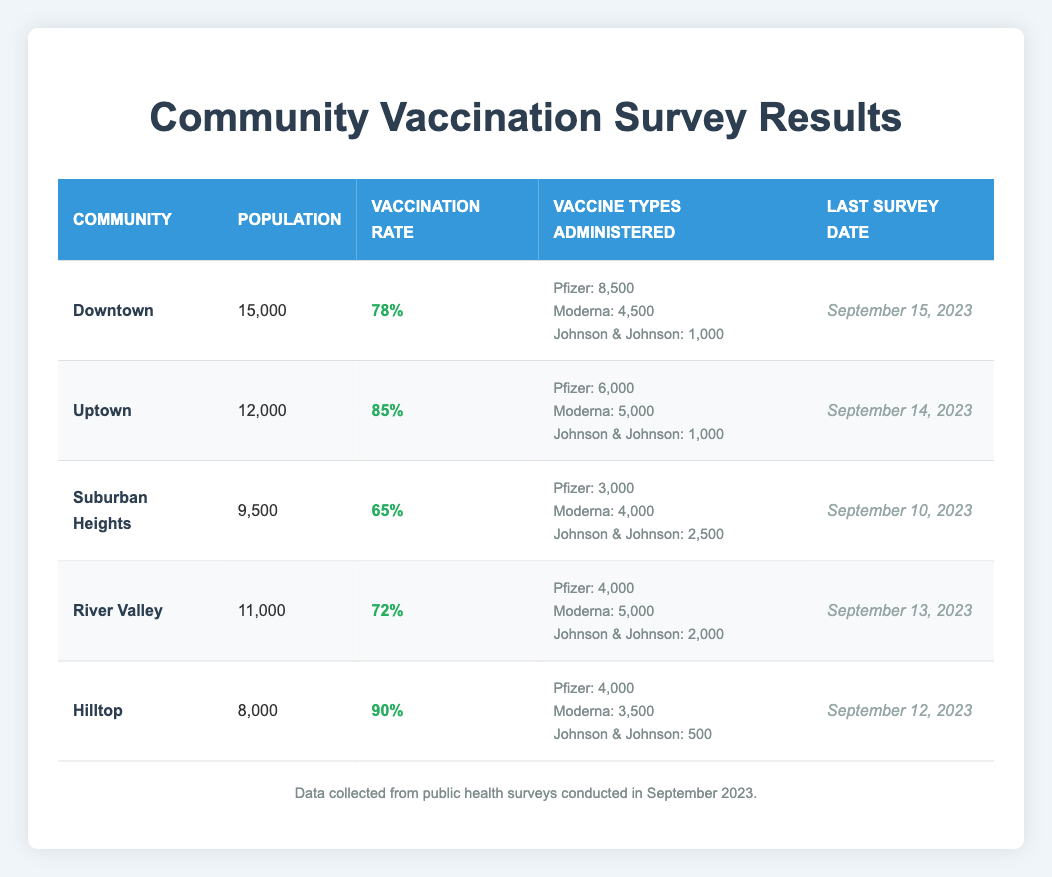What is the vaccination rate for Uptown? The vaccination rate for Uptown is directly listed in the table under the Vaccination Rate column.
Answer: 85% Which community has the highest vaccination rate? By examining the Vaccination Rate column, it is clear that Hilltop has the highest rate of 90%.
Answer: Hilltop What is the total population of all communities combined? The populations of each community are added together: 15000 (Downtown) + 12000 (Uptown) + 9500 (Suburban Heights) + 11000 (River Valley) + 8000 (Hilltop) = 60500.
Answer: 60500 Are there more people vaccinated with Pfizer than with Moderna in the Downtown community? In Downtown, 8500 people received Pfizer and 4500 received Moderna. Since 8500 is greater than 4500, the answer is yes.
Answer: Yes What is the average vaccination rate across all communities? To find the average vaccination rate, sum the rates (78 + 85 + 65 + 72 + 90) = 390 and divide by the number of communities, which is 5: 390/5 = 78.
Answer: 78 How many doses of the Johnson & Johnson vaccine were administered in the Suburban Heights community? The number of doses administered for Johnson & Johnson in Suburban Heights is directly listed in the Vaccine Types Administered section. It shows 2500 doses were given.
Answer: 2500 Is the Last Survey Date for River Valley after that of Uptown? The Last Survey Date for River Valley is September 13, 2023, while that for Uptown is September 14, 2023. Since September 13 is before September 14, the answer is no.
Answer: No What is the difference in population between Hilltop and Suburban Heights? The population of Hilltop is 8000 and the population of Suburban Heights is 9500. The difference is calculated as 9500 - 8000 = 1500.
Answer: 1500 How many more people were vaccinated with Moderna compared to Johnson & Johnson in the River Valley community? In River Valley, 5000 people were vaccinated with Moderna and 2000 with Johnson & Johnson. The difference is 5000 - 2000 = 3000.
Answer: 3000 